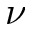<formula> <loc_0><loc_0><loc_500><loc_500>\nu</formula> 